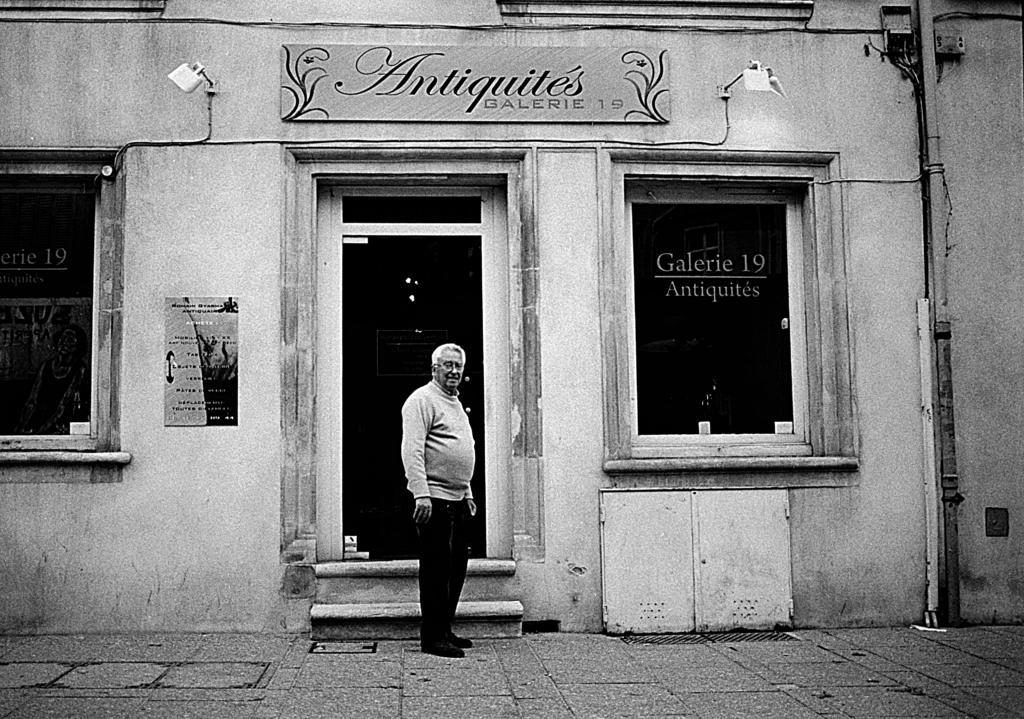Can you describe this image briefly? In this I can see it is a black and white in this a man is standing, he wore sweater, trouser, spectacles. Behind him there is a glass door, at the top there is the name board on the wall. 